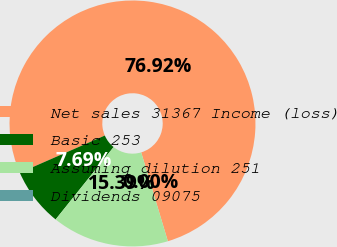<chart> <loc_0><loc_0><loc_500><loc_500><pie_chart><fcel>Net sales 31367 Income (loss)<fcel>Basic 253<fcel>Assuming dilution 251<fcel>Dividends 09075<nl><fcel>76.92%<fcel>7.69%<fcel>15.39%<fcel>0.0%<nl></chart> 